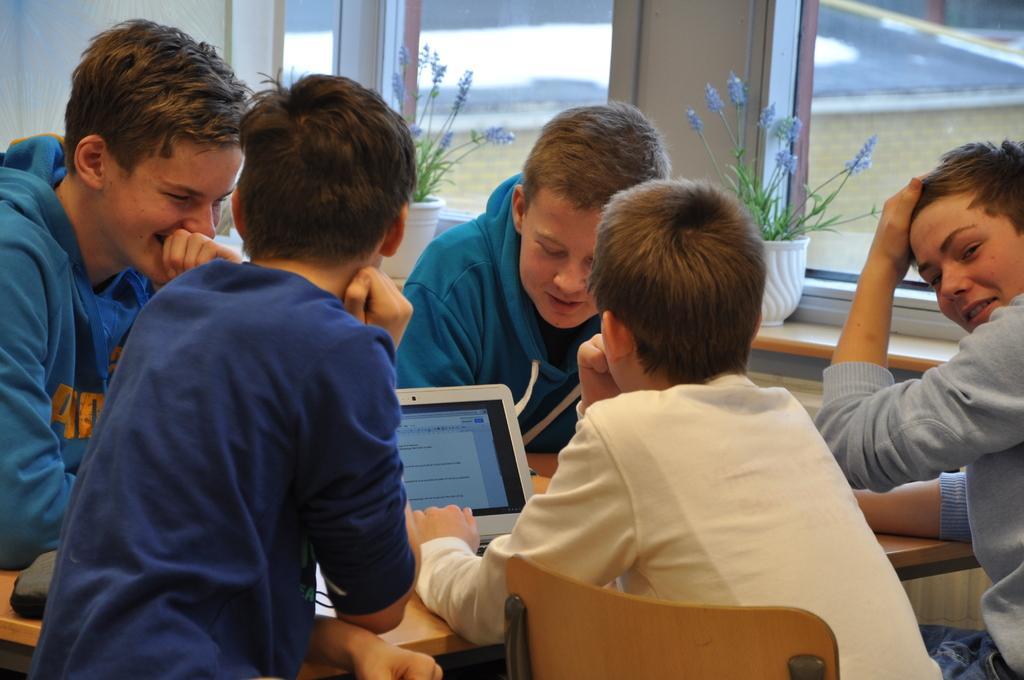Could you give a brief overview of what you see in this image? In the picture we can see some boys are sitting around the table with the chairs and watching something on the laptop and behind them, we can see the glass window and near it we can see two house plants. 